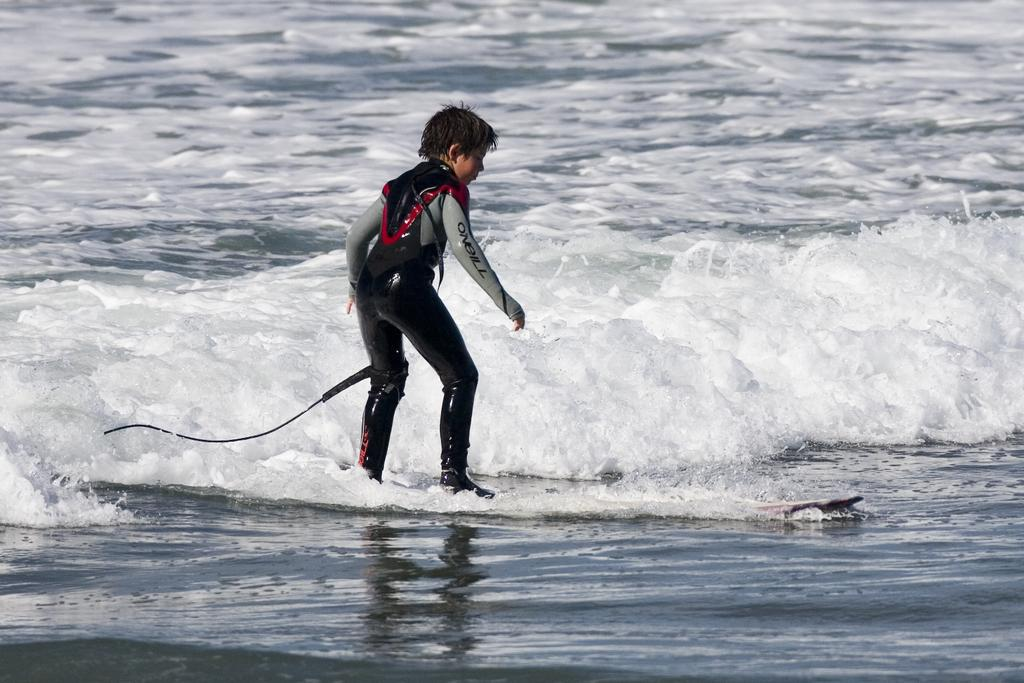<image>
Summarize the visual content of the image. The wet suit worn by the surfer is made by O'Neill. 